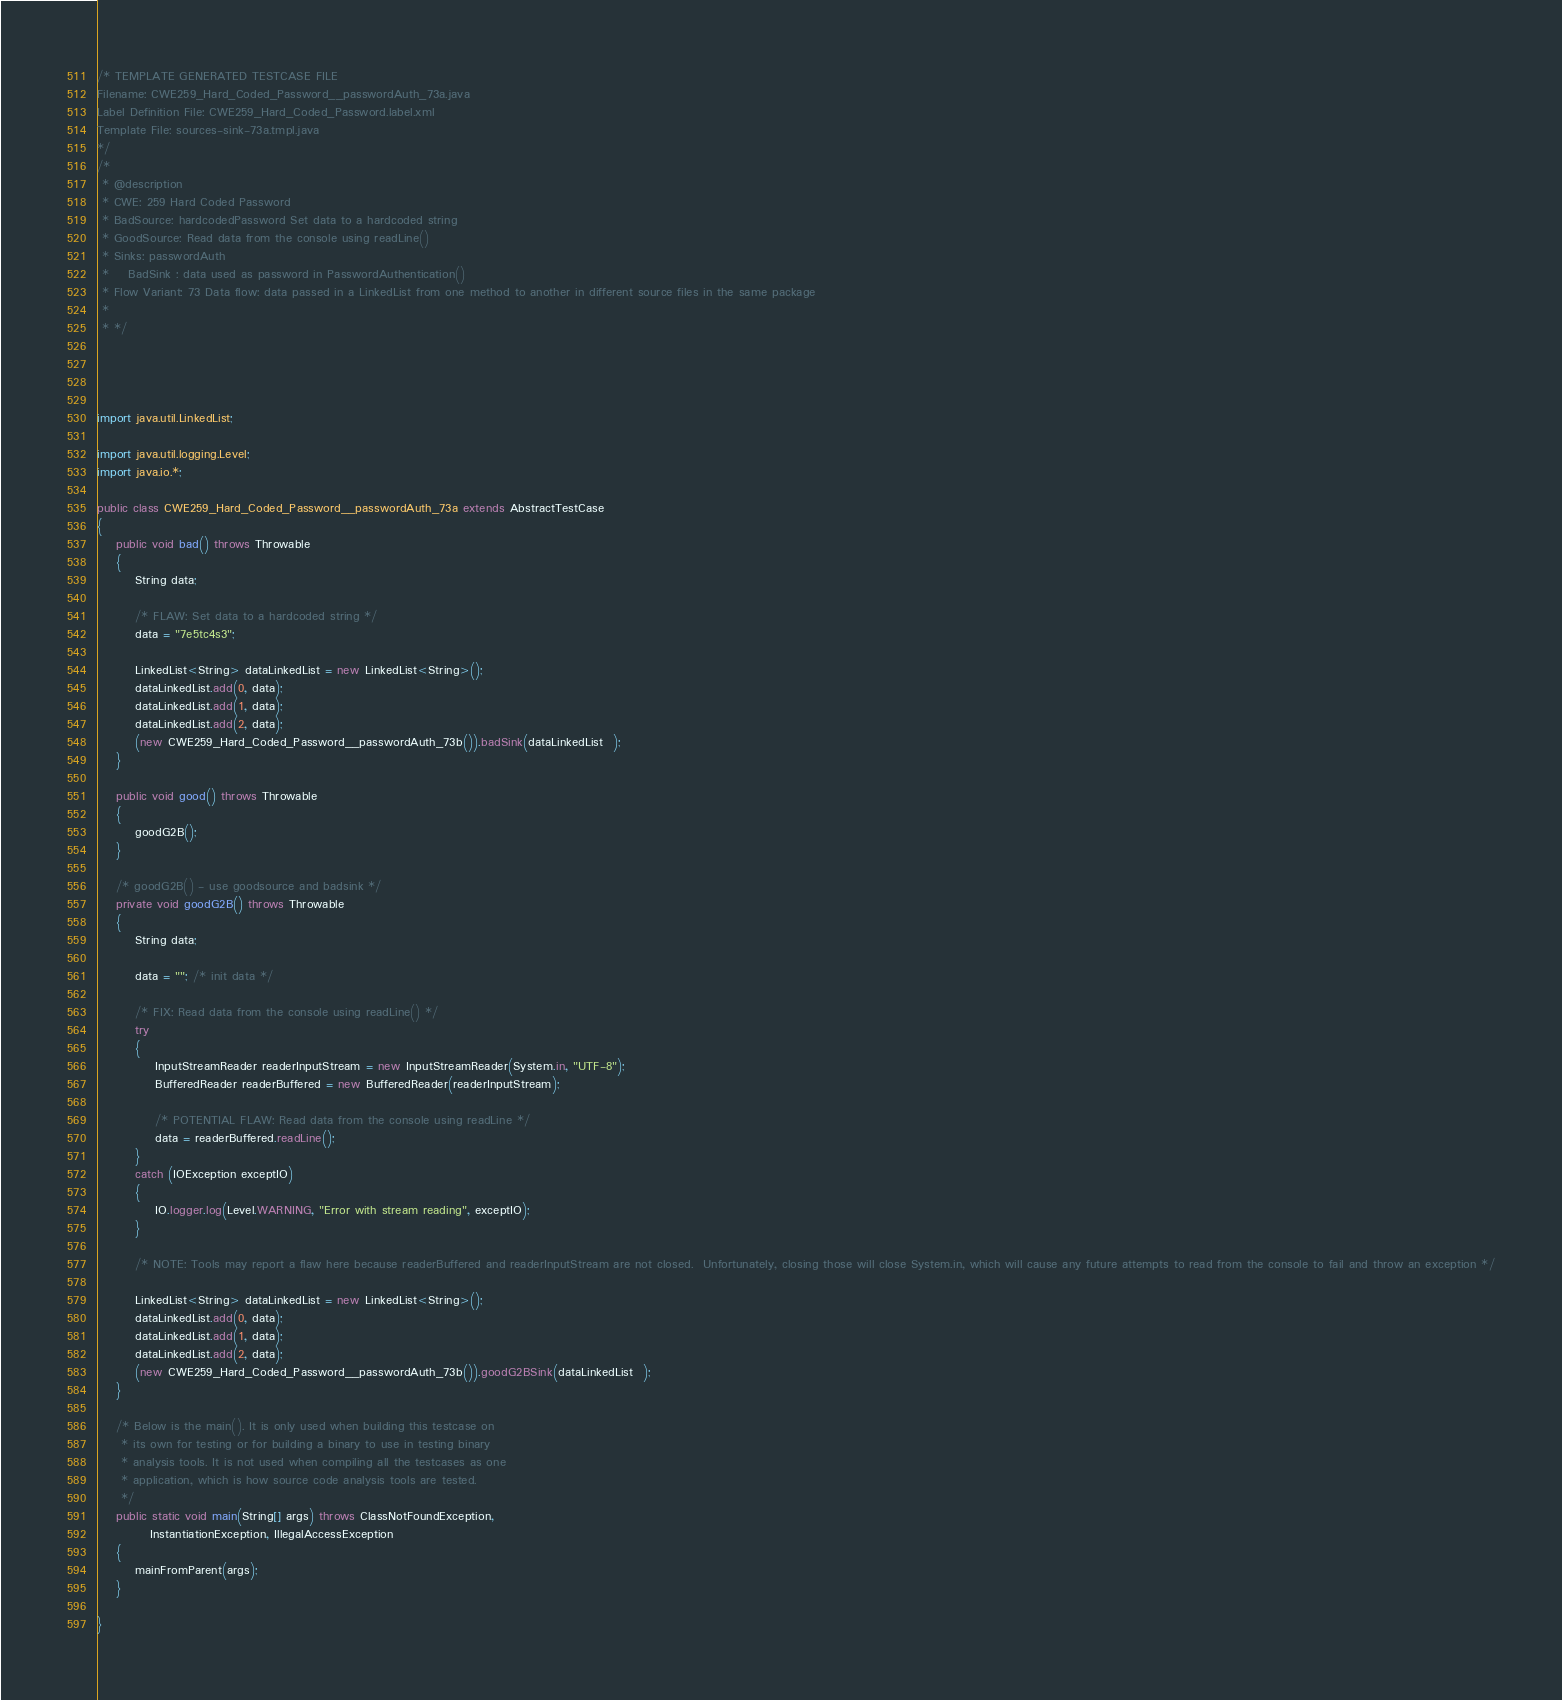Convert code to text. <code><loc_0><loc_0><loc_500><loc_500><_Java_>/* TEMPLATE GENERATED TESTCASE FILE
Filename: CWE259_Hard_Coded_Password__passwordAuth_73a.java
Label Definition File: CWE259_Hard_Coded_Password.label.xml
Template File: sources-sink-73a.tmpl.java
*/
/*
 * @description
 * CWE: 259 Hard Coded Password
 * BadSource: hardcodedPassword Set data to a hardcoded string
 * GoodSource: Read data from the console using readLine()
 * Sinks: passwordAuth
 *    BadSink : data used as password in PasswordAuthentication()
 * Flow Variant: 73 Data flow: data passed in a LinkedList from one method to another in different source files in the same package
 *
 * */




import java.util.LinkedList;

import java.util.logging.Level;
import java.io.*;

public class CWE259_Hard_Coded_Password__passwordAuth_73a extends AbstractTestCase
{
    public void bad() throws Throwable
    {
        String data;

        /* FLAW: Set data to a hardcoded string */
        data = "7e5tc4s3";

        LinkedList<String> dataLinkedList = new LinkedList<String>();
        dataLinkedList.add(0, data);
        dataLinkedList.add(1, data);
        dataLinkedList.add(2, data);
        (new CWE259_Hard_Coded_Password__passwordAuth_73b()).badSink(dataLinkedList  );
    }

    public void good() throws Throwable
    {
        goodG2B();
    }

    /* goodG2B() - use goodsource and badsink */
    private void goodG2B() throws Throwable
    {
        String data;

        data = ""; /* init data */

        /* FIX: Read data from the console using readLine() */
        try
        {
            InputStreamReader readerInputStream = new InputStreamReader(System.in, "UTF-8");
            BufferedReader readerBuffered = new BufferedReader(readerInputStream);

            /* POTENTIAL FLAW: Read data from the console using readLine */
            data = readerBuffered.readLine();
        }
        catch (IOException exceptIO)
        {
            IO.logger.log(Level.WARNING, "Error with stream reading", exceptIO);
        }

        /* NOTE: Tools may report a flaw here because readerBuffered and readerInputStream are not closed.  Unfortunately, closing those will close System.in, which will cause any future attempts to read from the console to fail and throw an exception */

        LinkedList<String> dataLinkedList = new LinkedList<String>();
        dataLinkedList.add(0, data);
        dataLinkedList.add(1, data);
        dataLinkedList.add(2, data);
        (new CWE259_Hard_Coded_Password__passwordAuth_73b()).goodG2BSink(dataLinkedList  );
    }

    /* Below is the main(). It is only used when building this testcase on
     * its own for testing or for building a binary to use in testing binary
     * analysis tools. It is not used when compiling all the testcases as one
     * application, which is how source code analysis tools are tested.
     */
    public static void main(String[] args) throws ClassNotFoundException,
           InstantiationException, IllegalAccessException
    {
        mainFromParent(args);
    }

}
</code> 